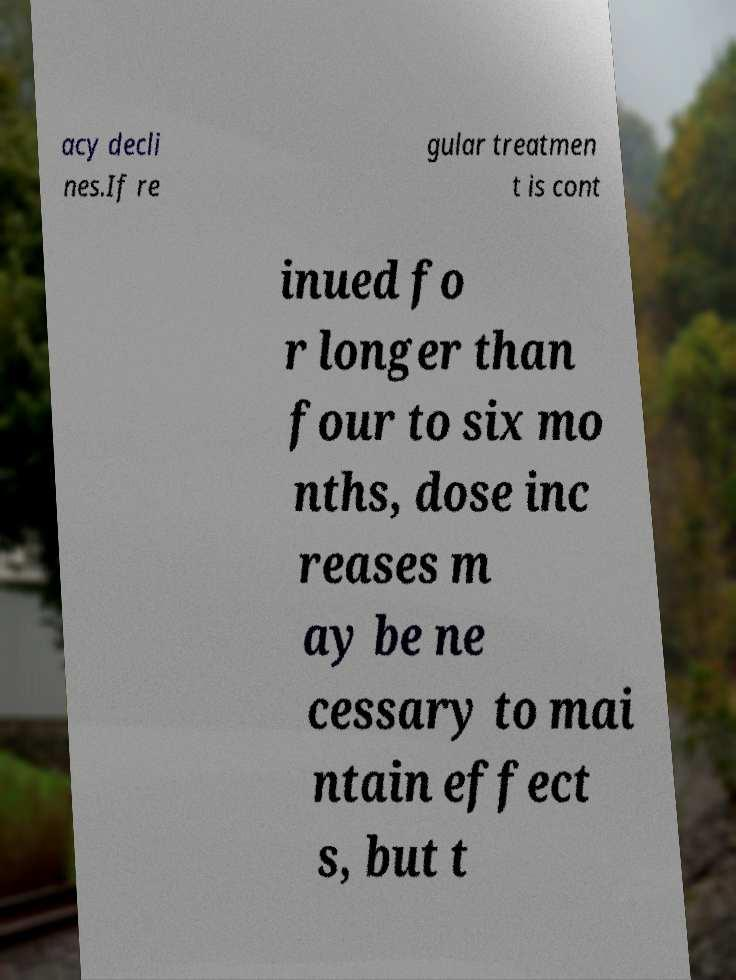Please read and relay the text visible in this image. What does it say? acy decli nes.If re gular treatmen t is cont inued fo r longer than four to six mo nths, dose inc reases m ay be ne cessary to mai ntain effect s, but t 